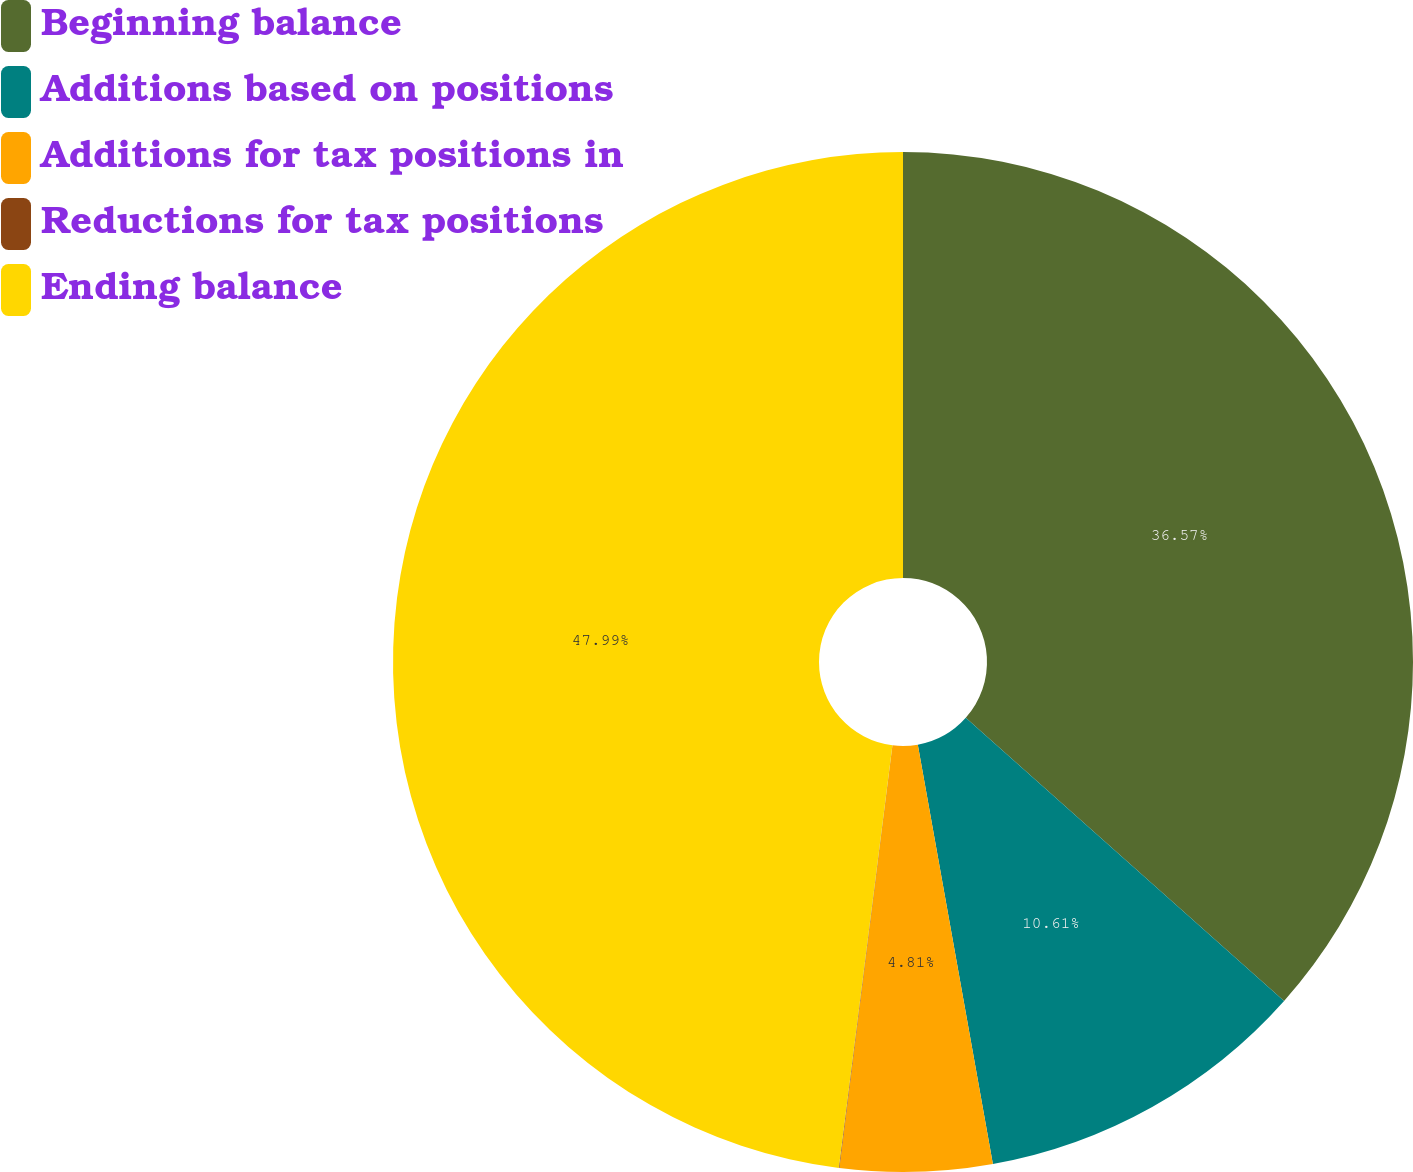Convert chart. <chart><loc_0><loc_0><loc_500><loc_500><pie_chart><fcel>Beginning balance<fcel>Additions based on positions<fcel>Additions for tax positions in<fcel>Reductions for tax positions<fcel>Ending balance<nl><fcel>36.57%<fcel>10.61%<fcel>4.81%<fcel>0.02%<fcel>47.99%<nl></chart> 